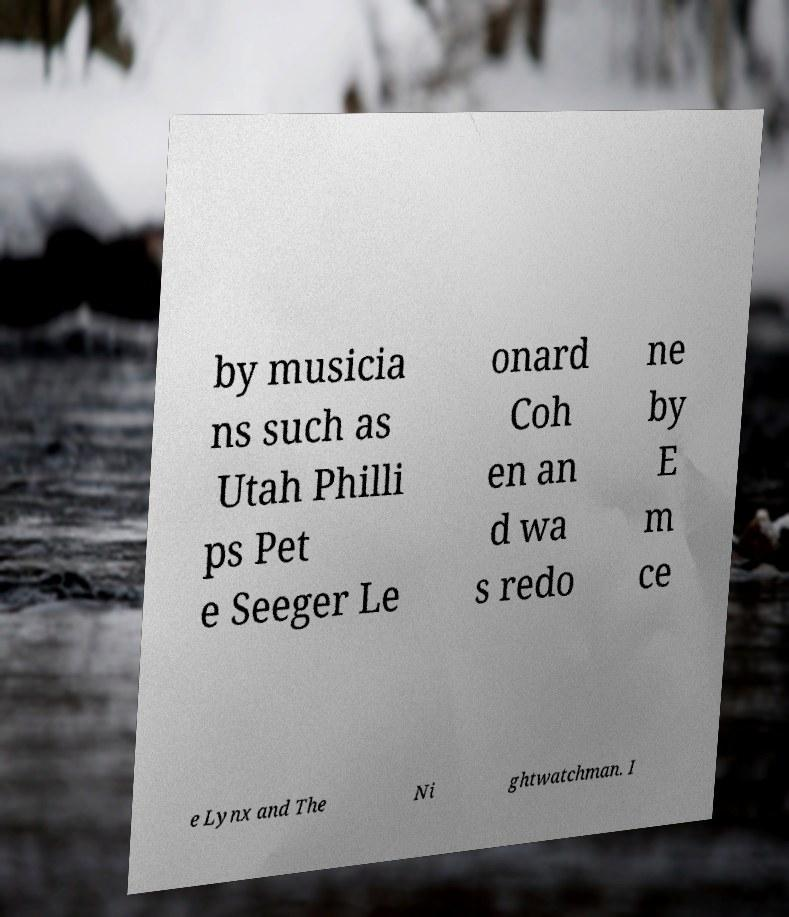Please read and relay the text visible in this image. What does it say? by musicia ns such as Utah Philli ps Pet e Seeger Le onard Coh en an d wa s redo ne by E m ce e Lynx and The Ni ghtwatchman. I 